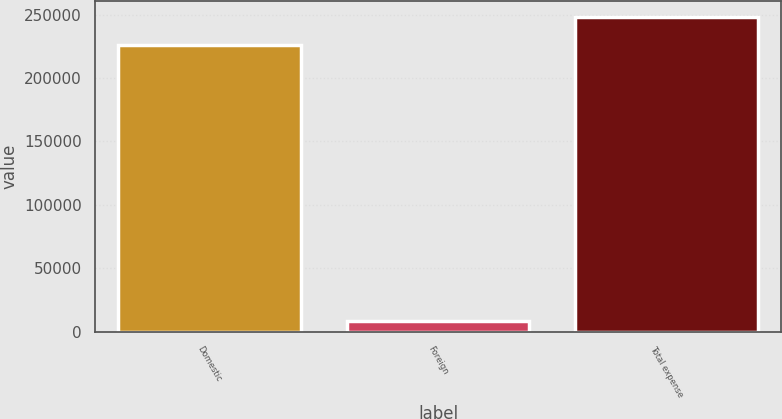<chart> <loc_0><loc_0><loc_500><loc_500><bar_chart><fcel>Domestic<fcel>Foreign<fcel>Total expense<nl><fcel>225694<fcel>8803<fcel>248263<nl></chart> 